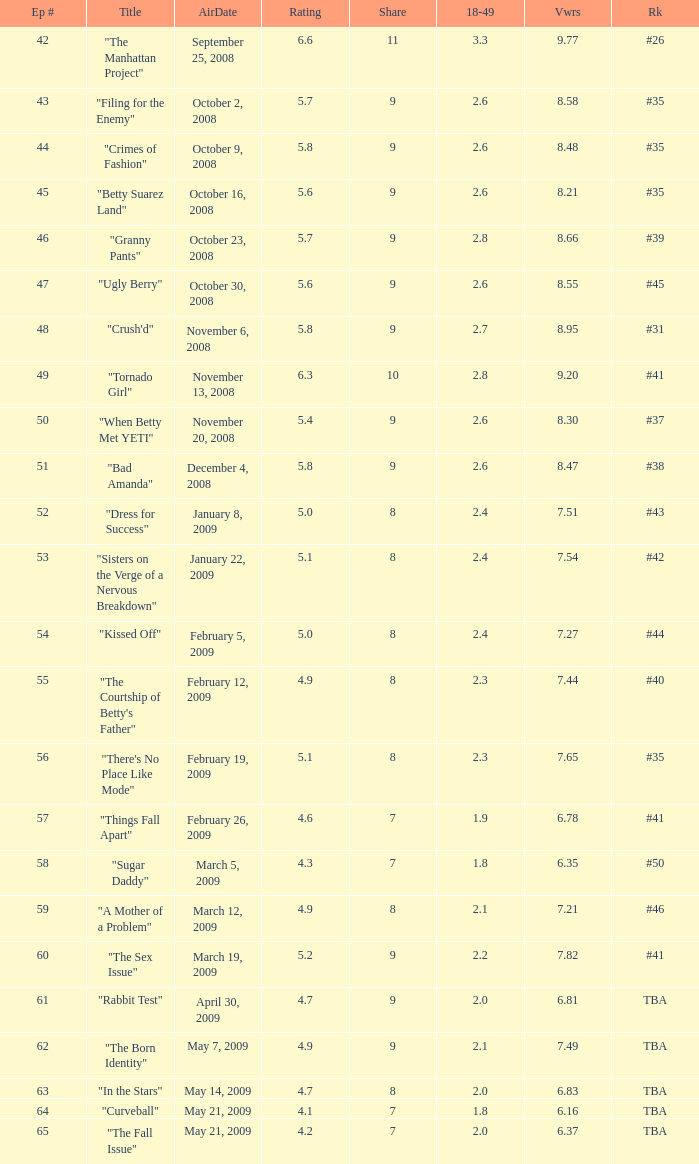Can you parse all the data within this table? {'header': ['Ep #', 'Title', 'AirDate', 'Rating', 'Share', '18-49', 'Vwrs', 'Rk'], 'rows': [['42', '"The Manhattan Project"', 'September 25, 2008', '6.6', '11', '3.3', '9.77', '#26'], ['43', '"Filing for the Enemy"', 'October 2, 2008', '5.7', '9', '2.6', '8.58', '#35'], ['44', '"Crimes of Fashion"', 'October 9, 2008', '5.8', '9', '2.6', '8.48', '#35'], ['45', '"Betty Suarez Land"', 'October 16, 2008', '5.6', '9', '2.6', '8.21', '#35'], ['46', '"Granny Pants"', 'October 23, 2008', '5.7', '9', '2.8', '8.66', '#39'], ['47', '"Ugly Berry"', 'October 30, 2008', '5.6', '9', '2.6', '8.55', '#45'], ['48', '"Crush\'d"', 'November 6, 2008', '5.8', '9', '2.7', '8.95', '#31'], ['49', '"Tornado Girl"', 'November 13, 2008', '6.3', '10', '2.8', '9.20', '#41'], ['50', '"When Betty Met YETI"', 'November 20, 2008', '5.4', '9', '2.6', '8.30', '#37'], ['51', '"Bad Amanda"', 'December 4, 2008', '5.8', '9', '2.6', '8.47', '#38'], ['52', '"Dress for Success"', 'January 8, 2009', '5.0', '8', '2.4', '7.51', '#43'], ['53', '"Sisters on the Verge of a Nervous Breakdown"', 'January 22, 2009', '5.1', '8', '2.4', '7.54', '#42'], ['54', '"Kissed Off"', 'February 5, 2009', '5.0', '8', '2.4', '7.27', '#44'], ['55', '"The Courtship of Betty\'s Father"', 'February 12, 2009', '4.9', '8', '2.3', '7.44', '#40'], ['56', '"There\'s No Place Like Mode"', 'February 19, 2009', '5.1', '8', '2.3', '7.65', '#35'], ['57', '"Things Fall Apart"', 'February 26, 2009', '4.6', '7', '1.9', '6.78', '#41'], ['58', '"Sugar Daddy"', 'March 5, 2009', '4.3', '7', '1.8', '6.35', '#50'], ['59', '"A Mother of a Problem"', 'March 12, 2009', '4.9', '8', '2.1', '7.21', '#46'], ['60', '"The Sex Issue"', 'March 19, 2009', '5.2', '9', '2.2', '7.82', '#41'], ['61', '"Rabbit Test"', 'April 30, 2009', '4.7', '9', '2.0', '6.81', 'TBA'], ['62', '"The Born Identity"', 'May 7, 2009', '4.9', '9', '2.1', '7.49', 'TBA'], ['63', '"In the Stars"', 'May 14, 2009', '4.7', '8', '2.0', '6.83', 'TBA'], ['64', '"Curveball"', 'May 21, 2009', '4.1', '7', '1.8', '6.16', 'TBA'], ['65', '"The Fall Issue"', 'May 21, 2009', '4.2', '7', '2.0', '6.37', 'TBA']]} What is the lowest Viewers that has an Episode #higher than 58 with a title of "curveball" less than 4.1 rating? None. 